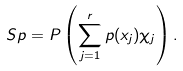Convert formula to latex. <formula><loc_0><loc_0><loc_500><loc_500>S p = P \left ( \sum _ { j = 1 } ^ { r } p ( x _ { j } ) \chi _ { j } \right ) .</formula> 